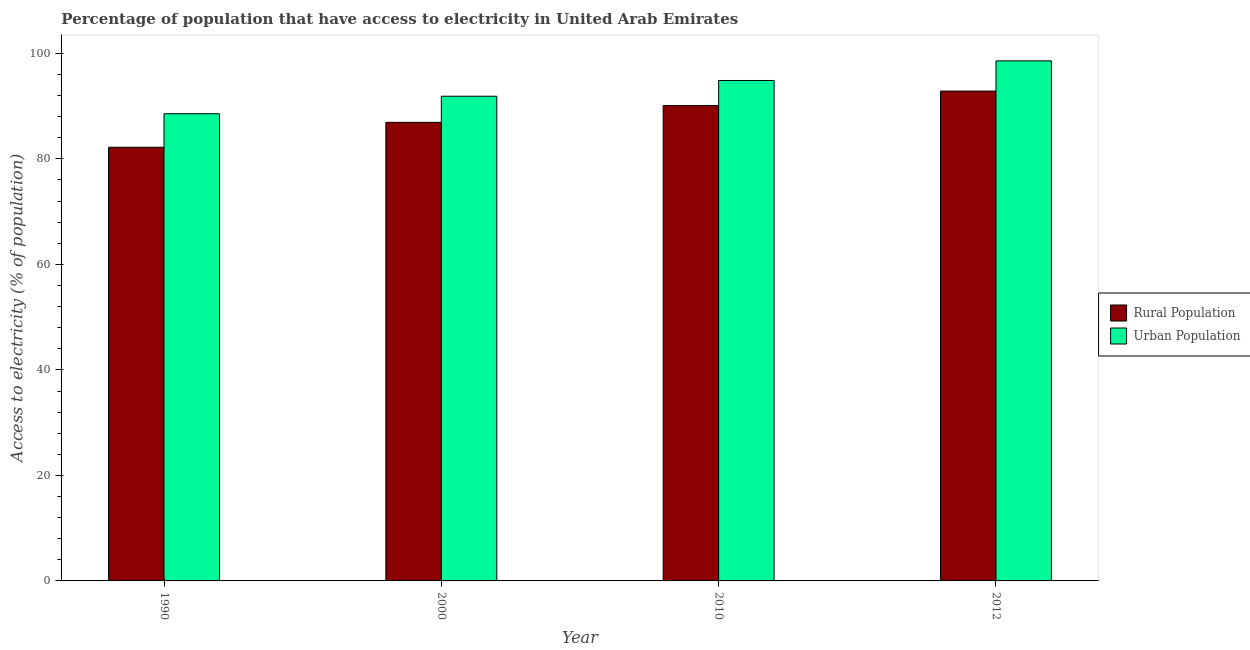How many different coloured bars are there?
Ensure brevity in your answer.  2. How many groups of bars are there?
Provide a succinct answer. 4. Are the number of bars on each tick of the X-axis equal?
Your answer should be very brief. Yes. How many bars are there on the 1st tick from the left?
Make the answer very short. 2. How many bars are there on the 4th tick from the right?
Provide a short and direct response. 2. What is the label of the 2nd group of bars from the left?
Offer a very short reply. 2000. What is the percentage of urban population having access to electricity in 1990?
Your answer should be very brief. 88.56. Across all years, what is the maximum percentage of rural population having access to electricity?
Make the answer very short. 92.85. Across all years, what is the minimum percentage of rural population having access to electricity?
Provide a short and direct response. 82.2. In which year was the percentage of rural population having access to electricity maximum?
Your answer should be very brief. 2012. What is the total percentage of rural population having access to electricity in the graph?
Provide a succinct answer. 352.08. What is the difference between the percentage of rural population having access to electricity in 2000 and that in 2012?
Provide a succinct answer. -5.93. What is the difference between the percentage of rural population having access to electricity in 2012 and the percentage of urban population having access to electricity in 2010?
Your response must be concise. 2.75. What is the average percentage of rural population having access to electricity per year?
Your answer should be compact. 88.02. In how many years, is the percentage of rural population having access to electricity greater than 16 %?
Offer a very short reply. 4. What is the ratio of the percentage of rural population having access to electricity in 2000 to that in 2012?
Your answer should be compact. 0.94. What is the difference between the highest and the second highest percentage of rural population having access to electricity?
Keep it short and to the point. 2.75. What is the difference between the highest and the lowest percentage of urban population having access to electricity?
Make the answer very short. 10.02. What does the 1st bar from the left in 2010 represents?
Provide a succinct answer. Rural Population. What does the 2nd bar from the right in 1990 represents?
Give a very brief answer. Rural Population. Are all the bars in the graph horizontal?
Give a very brief answer. No. How many legend labels are there?
Your answer should be very brief. 2. How are the legend labels stacked?
Make the answer very short. Vertical. What is the title of the graph?
Provide a succinct answer. Percentage of population that have access to electricity in United Arab Emirates. What is the label or title of the Y-axis?
Keep it short and to the point. Access to electricity (% of population). What is the Access to electricity (% of population) in Rural Population in 1990?
Your response must be concise. 82.2. What is the Access to electricity (% of population) of Urban Population in 1990?
Your answer should be compact. 88.56. What is the Access to electricity (% of population) in Rural Population in 2000?
Ensure brevity in your answer.  86.93. What is the Access to electricity (% of population) in Urban Population in 2000?
Provide a succinct answer. 91.88. What is the Access to electricity (% of population) in Rural Population in 2010?
Your answer should be compact. 90.1. What is the Access to electricity (% of population) in Urban Population in 2010?
Your answer should be compact. 94.86. What is the Access to electricity (% of population) in Rural Population in 2012?
Ensure brevity in your answer.  92.85. What is the Access to electricity (% of population) of Urban Population in 2012?
Provide a short and direct response. 98.58. Across all years, what is the maximum Access to electricity (% of population) in Rural Population?
Provide a succinct answer. 92.85. Across all years, what is the maximum Access to electricity (% of population) in Urban Population?
Offer a very short reply. 98.58. Across all years, what is the minimum Access to electricity (% of population) of Rural Population?
Provide a short and direct response. 82.2. Across all years, what is the minimum Access to electricity (% of population) of Urban Population?
Provide a short and direct response. 88.56. What is the total Access to electricity (% of population) in Rural Population in the graph?
Provide a succinct answer. 352.08. What is the total Access to electricity (% of population) of Urban Population in the graph?
Ensure brevity in your answer.  373.87. What is the difference between the Access to electricity (% of population) in Rural Population in 1990 and that in 2000?
Give a very brief answer. -4.72. What is the difference between the Access to electricity (% of population) in Urban Population in 1990 and that in 2000?
Your answer should be compact. -3.32. What is the difference between the Access to electricity (% of population) in Rural Population in 1990 and that in 2010?
Ensure brevity in your answer.  -7.9. What is the difference between the Access to electricity (% of population) in Urban Population in 1990 and that in 2010?
Provide a succinct answer. -6.3. What is the difference between the Access to electricity (% of population) in Rural Population in 1990 and that in 2012?
Your response must be concise. -10.65. What is the difference between the Access to electricity (% of population) in Urban Population in 1990 and that in 2012?
Provide a succinct answer. -10.02. What is the difference between the Access to electricity (% of population) in Rural Population in 2000 and that in 2010?
Make the answer very short. -3.17. What is the difference between the Access to electricity (% of population) in Urban Population in 2000 and that in 2010?
Provide a succinct answer. -2.98. What is the difference between the Access to electricity (% of population) of Rural Population in 2000 and that in 2012?
Ensure brevity in your answer.  -5.93. What is the difference between the Access to electricity (% of population) of Urban Population in 2000 and that in 2012?
Make the answer very short. -6.7. What is the difference between the Access to electricity (% of population) in Rural Population in 2010 and that in 2012?
Make the answer very short. -2.75. What is the difference between the Access to electricity (% of population) of Urban Population in 2010 and that in 2012?
Ensure brevity in your answer.  -3.72. What is the difference between the Access to electricity (% of population) of Rural Population in 1990 and the Access to electricity (% of population) of Urban Population in 2000?
Make the answer very short. -9.67. What is the difference between the Access to electricity (% of population) of Rural Population in 1990 and the Access to electricity (% of population) of Urban Population in 2010?
Give a very brief answer. -12.66. What is the difference between the Access to electricity (% of population) in Rural Population in 1990 and the Access to electricity (% of population) in Urban Population in 2012?
Make the answer very short. -16.37. What is the difference between the Access to electricity (% of population) of Rural Population in 2000 and the Access to electricity (% of population) of Urban Population in 2010?
Your response must be concise. -7.93. What is the difference between the Access to electricity (% of population) in Rural Population in 2000 and the Access to electricity (% of population) in Urban Population in 2012?
Ensure brevity in your answer.  -11.65. What is the difference between the Access to electricity (% of population) in Rural Population in 2010 and the Access to electricity (% of population) in Urban Population in 2012?
Offer a terse response. -8.48. What is the average Access to electricity (% of population) of Rural Population per year?
Ensure brevity in your answer.  88.02. What is the average Access to electricity (% of population) in Urban Population per year?
Your answer should be very brief. 93.47. In the year 1990, what is the difference between the Access to electricity (% of population) in Rural Population and Access to electricity (% of population) in Urban Population?
Provide a succinct answer. -6.36. In the year 2000, what is the difference between the Access to electricity (% of population) in Rural Population and Access to electricity (% of population) in Urban Population?
Your answer should be very brief. -4.95. In the year 2010, what is the difference between the Access to electricity (% of population) of Rural Population and Access to electricity (% of population) of Urban Population?
Offer a very short reply. -4.76. In the year 2012, what is the difference between the Access to electricity (% of population) of Rural Population and Access to electricity (% of population) of Urban Population?
Provide a succinct answer. -5.72. What is the ratio of the Access to electricity (% of population) of Rural Population in 1990 to that in 2000?
Your answer should be compact. 0.95. What is the ratio of the Access to electricity (% of population) in Urban Population in 1990 to that in 2000?
Offer a very short reply. 0.96. What is the ratio of the Access to electricity (% of population) of Rural Population in 1990 to that in 2010?
Make the answer very short. 0.91. What is the ratio of the Access to electricity (% of population) in Urban Population in 1990 to that in 2010?
Offer a very short reply. 0.93. What is the ratio of the Access to electricity (% of population) of Rural Population in 1990 to that in 2012?
Provide a short and direct response. 0.89. What is the ratio of the Access to electricity (% of population) of Urban Population in 1990 to that in 2012?
Offer a very short reply. 0.9. What is the ratio of the Access to electricity (% of population) in Rural Population in 2000 to that in 2010?
Keep it short and to the point. 0.96. What is the ratio of the Access to electricity (% of population) in Urban Population in 2000 to that in 2010?
Make the answer very short. 0.97. What is the ratio of the Access to electricity (% of population) in Rural Population in 2000 to that in 2012?
Provide a short and direct response. 0.94. What is the ratio of the Access to electricity (% of population) of Urban Population in 2000 to that in 2012?
Keep it short and to the point. 0.93. What is the ratio of the Access to electricity (% of population) in Rural Population in 2010 to that in 2012?
Offer a terse response. 0.97. What is the ratio of the Access to electricity (% of population) of Urban Population in 2010 to that in 2012?
Your response must be concise. 0.96. What is the difference between the highest and the second highest Access to electricity (% of population) of Rural Population?
Keep it short and to the point. 2.75. What is the difference between the highest and the second highest Access to electricity (% of population) of Urban Population?
Offer a terse response. 3.72. What is the difference between the highest and the lowest Access to electricity (% of population) of Rural Population?
Offer a very short reply. 10.65. What is the difference between the highest and the lowest Access to electricity (% of population) in Urban Population?
Offer a very short reply. 10.02. 